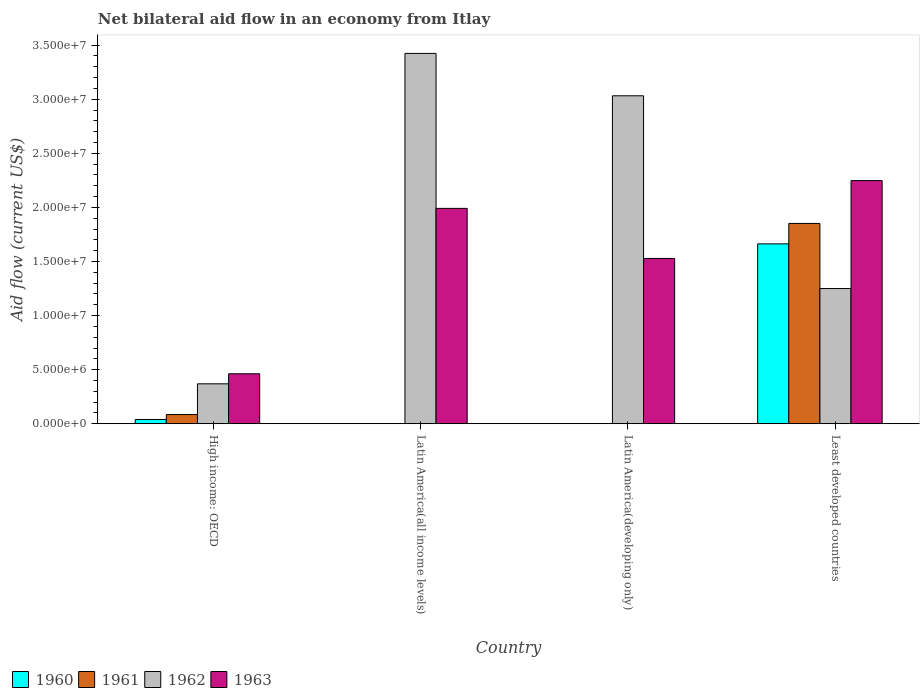How many different coloured bars are there?
Your answer should be compact. 4. Are the number of bars per tick equal to the number of legend labels?
Keep it short and to the point. No. Are the number of bars on each tick of the X-axis equal?
Your answer should be very brief. No. How many bars are there on the 4th tick from the left?
Ensure brevity in your answer.  4. What is the label of the 2nd group of bars from the left?
Your answer should be very brief. Latin America(all income levels). What is the net bilateral aid flow in 1961 in Least developed countries?
Make the answer very short. 1.85e+07. Across all countries, what is the maximum net bilateral aid flow in 1960?
Your answer should be very brief. 1.66e+07. Across all countries, what is the minimum net bilateral aid flow in 1961?
Your answer should be compact. 0. In which country was the net bilateral aid flow in 1961 maximum?
Offer a terse response. Least developed countries. What is the total net bilateral aid flow in 1963 in the graph?
Keep it short and to the point. 6.23e+07. What is the difference between the net bilateral aid flow in 1962 in Latin America(all income levels) and that in Least developed countries?
Your answer should be very brief. 2.17e+07. What is the difference between the net bilateral aid flow in 1961 in Latin America(developing only) and the net bilateral aid flow in 1960 in Least developed countries?
Ensure brevity in your answer.  -1.66e+07. What is the average net bilateral aid flow in 1962 per country?
Your answer should be very brief. 2.02e+07. What is the difference between the net bilateral aid flow of/in 1963 and net bilateral aid flow of/in 1962 in High income: OECD?
Offer a very short reply. 9.30e+05. What is the ratio of the net bilateral aid flow in 1963 in High income: OECD to that in Latin America(all income levels)?
Offer a very short reply. 0.23. Is the net bilateral aid flow in 1963 in Latin America(developing only) less than that in Least developed countries?
Make the answer very short. Yes. Is the difference between the net bilateral aid flow in 1963 in Latin America(all income levels) and Latin America(developing only) greater than the difference between the net bilateral aid flow in 1962 in Latin America(all income levels) and Latin America(developing only)?
Ensure brevity in your answer.  Yes. What is the difference between the highest and the second highest net bilateral aid flow in 1963?
Your answer should be compact. 2.57e+06. What is the difference between the highest and the lowest net bilateral aid flow in 1962?
Ensure brevity in your answer.  3.06e+07. Is it the case that in every country, the sum of the net bilateral aid flow in 1963 and net bilateral aid flow in 1962 is greater than the sum of net bilateral aid flow in 1961 and net bilateral aid flow in 1960?
Your answer should be compact. No. How many bars are there?
Offer a terse response. 12. Are the values on the major ticks of Y-axis written in scientific E-notation?
Offer a terse response. Yes. Does the graph contain grids?
Your response must be concise. No. Where does the legend appear in the graph?
Provide a short and direct response. Bottom left. How many legend labels are there?
Your answer should be compact. 4. What is the title of the graph?
Your answer should be compact. Net bilateral aid flow in an economy from Itlay. What is the label or title of the X-axis?
Provide a short and direct response. Country. What is the label or title of the Y-axis?
Ensure brevity in your answer.  Aid flow (current US$). What is the Aid flow (current US$) of 1961 in High income: OECD?
Provide a succinct answer. 8.50e+05. What is the Aid flow (current US$) in 1962 in High income: OECD?
Provide a succinct answer. 3.69e+06. What is the Aid flow (current US$) in 1963 in High income: OECD?
Your answer should be very brief. 4.62e+06. What is the Aid flow (current US$) in 1960 in Latin America(all income levels)?
Offer a terse response. 0. What is the Aid flow (current US$) of 1962 in Latin America(all income levels)?
Your answer should be very brief. 3.42e+07. What is the Aid flow (current US$) of 1963 in Latin America(all income levels)?
Offer a terse response. 1.99e+07. What is the Aid flow (current US$) in 1962 in Latin America(developing only)?
Make the answer very short. 3.03e+07. What is the Aid flow (current US$) of 1963 in Latin America(developing only)?
Provide a short and direct response. 1.53e+07. What is the Aid flow (current US$) in 1960 in Least developed countries?
Your response must be concise. 1.66e+07. What is the Aid flow (current US$) of 1961 in Least developed countries?
Provide a short and direct response. 1.85e+07. What is the Aid flow (current US$) of 1962 in Least developed countries?
Give a very brief answer. 1.25e+07. What is the Aid flow (current US$) in 1963 in Least developed countries?
Make the answer very short. 2.25e+07. Across all countries, what is the maximum Aid flow (current US$) in 1960?
Provide a succinct answer. 1.66e+07. Across all countries, what is the maximum Aid flow (current US$) of 1961?
Provide a short and direct response. 1.85e+07. Across all countries, what is the maximum Aid flow (current US$) of 1962?
Your answer should be compact. 3.42e+07. Across all countries, what is the maximum Aid flow (current US$) of 1963?
Provide a short and direct response. 2.25e+07. Across all countries, what is the minimum Aid flow (current US$) in 1960?
Make the answer very short. 0. Across all countries, what is the minimum Aid flow (current US$) of 1961?
Your answer should be very brief. 0. Across all countries, what is the minimum Aid flow (current US$) in 1962?
Give a very brief answer. 3.69e+06. Across all countries, what is the minimum Aid flow (current US$) of 1963?
Make the answer very short. 4.62e+06. What is the total Aid flow (current US$) of 1960 in the graph?
Ensure brevity in your answer.  1.70e+07. What is the total Aid flow (current US$) in 1961 in the graph?
Provide a short and direct response. 1.94e+07. What is the total Aid flow (current US$) of 1962 in the graph?
Ensure brevity in your answer.  8.08e+07. What is the total Aid flow (current US$) in 1963 in the graph?
Offer a very short reply. 6.23e+07. What is the difference between the Aid flow (current US$) of 1962 in High income: OECD and that in Latin America(all income levels)?
Your response must be concise. -3.06e+07. What is the difference between the Aid flow (current US$) of 1963 in High income: OECD and that in Latin America(all income levels)?
Keep it short and to the point. -1.53e+07. What is the difference between the Aid flow (current US$) in 1962 in High income: OECD and that in Latin America(developing only)?
Offer a terse response. -2.66e+07. What is the difference between the Aid flow (current US$) of 1963 in High income: OECD and that in Latin America(developing only)?
Provide a succinct answer. -1.07e+07. What is the difference between the Aid flow (current US$) of 1960 in High income: OECD and that in Least developed countries?
Offer a terse response. -1.62e+07. What is the difference between the Aid flow (current US$) of 1961 in High income: OECD and that in Least developed countries?
Offer a terse response. -1.77e+07. What is the difference between the Aid flow (current US$) in 1962 in High income: OECD and that in Least developed countries?
Offer a very short reply. -8.81e+06. What is the difference between the Aid flow (current US$) of 1963 in High income: OECD and that in Least developed countries?
Make the answer very short. -1.79e+07. What is the difference between the Aid flow (current US$) of 1962 in Latin America(all income levels) and that in Latin America(developing only)?
Your response must be concise. 3.92e+06. What is the difference between the Aid flow (current US$) of 1963 in Latin America(all income levels) and that in Latin America(developing only)?
Ensure brevity in your answer.  4.63e+06. What is the difference between the Aid flow (current US$) in 1962 in Latin America(all income levels) and that in Least developed countries?
Your answer should be compact. 2.17e+07. What is the difference between the Aid flow (current US$) of 1963 in Latin America(all income levels) and that in Least developed countries?
Provide a short and direct response. -2.57e+06. What is the difference between the Aid flow (current US$) in 1962 in Latin America(developing only) and that in Least developed countries?
Your answer should be very brief. 1.78e+07. What is the difference between the Aid flow (current US$) in 1963 in Latin America(developing only) and that in Least developed countries?
Your answer should be very brief. -7.20e+06. What is the difference between the Aid flow (current US$) of 1960 in High income: OECD and the Aid flow (current US$) of 1962 in Latin America(all income levels)?
Provide a short and direct response. -3.38e+07. What is the difference between the Aid flow (current US$) of 1960 in High income: OECD and the Aid flow (current US$) of 1963 in Latin America(all income levels)?
Keep it short and to the point. -1.95e+07. What is the difference between the Aid flow (current US$) of 1961 in High income: OECD and the Aid flow (current US$) of 1962 in Latin America(all income levels)?
Your answer should be very brief. -3.34e+07. What is the difference between the Aid flow (current US$) of 1961 in High income: OECD and the Aid flow (current US$) of 1963 in Latin America(all income levels)?
Offer a terse response. -1.91e+07. What is the difference between the Aid flow (current US$) of 1962 in High income: OECD and the Aid flow (current US$) of 1963 in Latin America(all income levels)?
Keep it short and to the point. -1.62e+07. What is the difference between the Aid flow (current US$) of 1960 in High income: OECD and the Aid flow (current US$) of 1962 in Latin America(developing only)?
Keep it short and to the point. -2.99e+07. What is the difference between the Aid flow (current US$) in 1960 in High income: OECD and the Aid flow (current US$) in 1963 in Latin America(developing only)?
Make the answer very short. -1.49e+07. What is the difference between the Aid flow (current US$) in 1961 in High income: OECD and the Aid flow (current US$) in 1962 in Latin America(developing only)?
Provide a short and direct response. -2.95e+07. What is the difference between the Aid flow (current US$) in 1961 in High income: OECD and the Aid flow (current US$) in 1963 in Latin America(developing only)?
Give a very brief answer. -1.44e+07. What is the difference between the Aid flow (current US$) in 1962 in High income: OECD and the Aid flow (current US$) in 1963 in Latin America(developing only)?
Offer a terse response. -1.16e+07. What is the difference between the Aid flow (current US$) in 1960 in High income: OECD and the Aid flow (current US$) in 1961 in Least developed countries?
Your response must be concise. -1.81e+07. What is the difference between the Aid flow (current US$) of 1960 in High income: OECD and the Aid flow (current US$) of 1962 in Least developed countries?
Offer a terse response. -1.21e+07. What is the difference between the Aid flow (current US$) in 1960 in High income: OECD and the Aid flow (current US$) in 1963 in Least developed countries?
Keep it short and to the point. -2.21e+07. What is the difference between the Aid flow (current US$) in 1961 in High income: OECD and the Aid flow (current US$) in 1962 in Least developed countries?
Keep it short and to the point. -1.16e+07. What is the difference between the Aid flow (current US$) of 1961 in High income: OECD and the Aid flow (current US$) of 1963 in Least developed countries?
Provide a succinct answer. -2.16e+07. What is the difference between the Aid flow (current US$) of 1962 in High income: OECD and the Aid flow (current US$) of 1963 in Least developed countries?
Offer a very short reply. -1.88e+07. What is the difference between the Aid flow (current US$) of 1962 in Latin America(all income levels) and the Aid flow (current US$) of 1963 in Latin America(developing only)?
Offer a terse response. 1.90e+07. What is the difference between the Aid flow (current US$) in 1962 in Latin America(all income levels) and the Aid flow (current US$) in 1963 in Least developed countries?
Offer a very short reply. 1.18e+07. What is the difference between the Aid flow (current US$) of 1962 in Latin America(developing only) and the Aid flow (current US$) of 1963 in Least developed countries?
Give a very brief answer. 7.84e+06. What is the average Aid flow (current US$) of 1960 per country?
Ensure brevity in your answer.  4.26e+06. What is the average Aid flow (current US$) of 1961 per country?
Your response must be concise. 4.84e+06. What is the average Aid flow (current US$) of 1962 per country?
Give a very brief answer. 2.02e+07. What is the average Aid flow (current US$) in 1963 per country?
Your response must be concise. 1.56e+07. What is the difference between the Aid flow (current US$) of 1960 and Aid flow (current US$) of 1961 in High income: OECD?
Provide a short and direct response. -4.60e+05. What is the difference between the Aid flow (current US$) in 1960 and Aid flow (current US$) in 1962 in High income: OECD?
Give a very brief answer. -3.30e+06. What is the difference between the Aid flow (current US$) of 1960 and Aid flow (current US$) of 1963 in High income: OECD?
Your response must be concise. -4.23e+06. What is the difference between the Aid flow (current US$) of 1961 and Aid flow (current US$) of 1962 in High income: OECD?
Ensure brevity in your answer.  -2.84e+06. What is the difference between the Aid flow (current US$) in 1961 and Aid flow (current US$) in 1963 in High income: OECD?
Offer a terse response. -3.77e+06. What is the difference between the Aid flow (current US$) of 1962 and Aid flow (current US$) of 1963 in High income: OECD?
Your answer should be very brief. -9.30e+05. What is the difference between the Aid flow (current US$) of 1962 and Aid flow (current US$) of 1963 in Latin America(all income levels)?
Give a very brief answer. 1.43e+07. What is the difference between the Aid flow (current US$) of 1962 and Aid flow (current US$) of 1963 in Latin America(developing only)?
Make the answer very short. 1.50e+07. What is the difference between the Aid flow (current US$) in 1960 and Aid flow (current US$) in 1961 in Least developed countries?
Provide a succinct answer. -1.89e+06. What is the difference between the Aid flow (current US$) of 1960 and Aid flow (current US$) of 1962 in Least developed countries?
Provide a succinct answer. 4.13e+06. What is the difference between the Aid flow (current US$) of 1960 and Aid flow (current US$) of 1963 in Least developed countries?
Your answer should be compact. -5.85e+06. What is the difference between the Aid flow (current US$) of 1961 and Aid flow (current US$) of 1962 in Least developed countries?
Your response must be concise. 6.02e+06. What is the difference between the Aid flow (current US$) in 1961 and Aid flow (current US$) in 1963 in Least developed countries?
Offer a terse response. -3.96e+06. What is the difference between the Aid flow (current US$) of 1962 and Aid flow (current US$) of 1963 in Least developed countries?
Your response must be concise. -9.98e+06. What is the ratio of the Aid flow (current US$) of 1962 in High income: OECD to that in Latin America(all income levels)?
Offer a terse response. 0.11. What is the ratio of the Aid flow (current US$) in 1963 in High income: OECD to that in Latin America(all income levels)?
Make the answer very short. 0.23. What is the ratio of the Aid flow (current US$) in 1962 in High income: OECD to that in Latin America(developing only)?
Provide a succinct answer. 0.12. What is the ratio of the Aid flow (current US$) in 1963 in High income: OECD to that in Latin America(developing only)?
Provide a short and direct response. 0.3. What is the ratio of the Aid flow (current US$) of 1960 in High income: OECD to that in Least developed countries?
Provide a succinct answer. 0.02. What is the ratio of the Aid flow (current US$) of 1961 in High income: OECD to that in Least developed countries?
Offer a terse response. 0.05. What is the ratio of the Aid flow (current US$) in 1962 in High income: OECD to that in Least developed countries?
Offer a terse response. 0.3. What is the ratio of the Aid flow (current US$) of 1963 in High income: OECD to that in Least developed countries?
Your answer should be compact. 0.21. What is the ratio of the Aid flow (current US$) of 1962 in Latin America(all income levels) to that in Latin America(developing only)?
Offer a terse response. 1.13. What is the ratio of the Aid flow (current US$) in 1963 in Latin America(all income levels) to that in Latin America(developing only)?
Offer a terse response. 1.3. What is the ratio of the Aid flow (current US$) of 1962 in Latin America(all income levels) to that in Least developed countries?
Provide a succinct answer. 2.74. What is the ratio of the Aid flow (current US$) in 1963 in Latin America(all income levels) to that in Least developed countries?
Your response must be concise. 0.89. What is the ratio of the Aid flow (current US$) of 1962 in Latin America(developing only) to that in Least developed countries?
Offer a terse response. 2.43. What is the ratio of the Aid flow (current US$) of 1963 in Latin America(developing only) to that in Least developed countries?
Keep it short and to the point. 0.68. What is the difference between the highest and the second highest Aid flow (current US$) of 1962?
Your answer should be very brief. 3.92e+06. What is the difference between the highest and the second highest Aid flow (current US$) of 1963?
Make the answer very short. 2.57e+06. What is the difference between the highest and the lowest Aid flow (current US$) in 1960?
Give a very brief answer. 1.66e+07. What is the difference between the highest and the lowest Aid flow (current US$) of 1961?
Provide a short and direct response. 1.85e+07. What is the difference between the highest and the lowest Aid flow (current US$) in 1962?
Offer a terse response. 3.06e+07. What is the difference between the highest and the lowest Aid flow (current US$) in 1963?
Provide a succinct answer. 1.79e+07. 